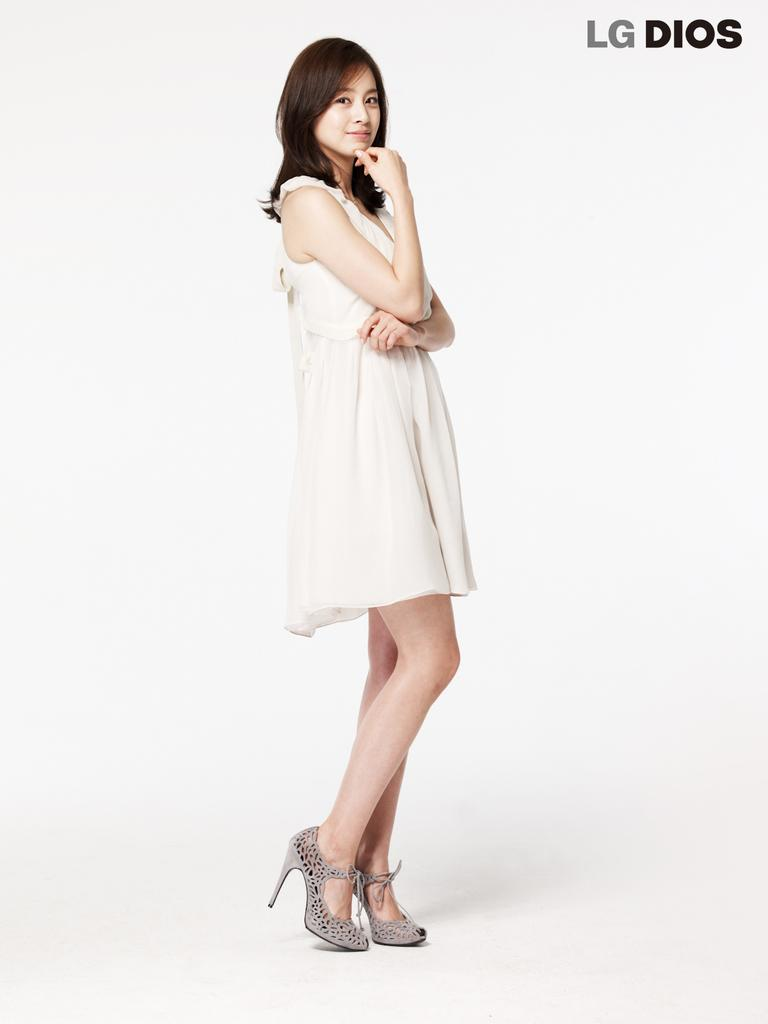Who or what is present in the image? There is a person in the image. What can be seen at the top of the image? There is text at the top of the image. What type of silk is being used by the person in the image? There is no silk present in the image, and the person's clothing or accessories are not mentioned in the provided facts. 